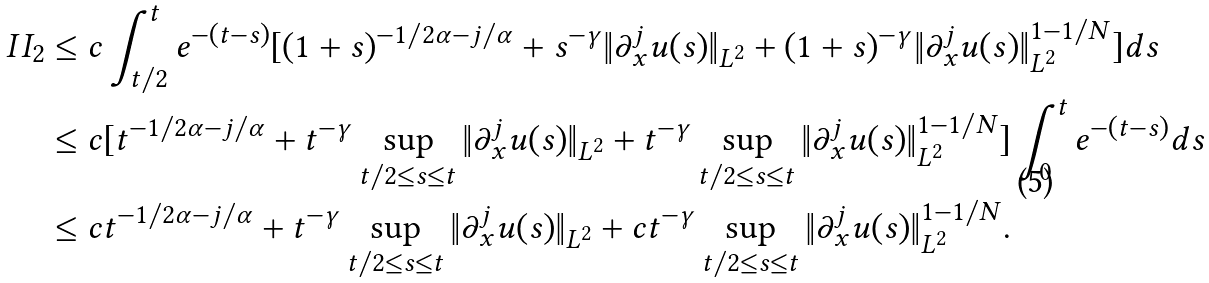Convert formula to latex. <formula><loc_0><loc_0><loc_500><loc_500>I I _ { 2 } & \leq c \int _ { t / 2 } ^ { t } e ^ { - ( t - s ) } [ ( 1 + s ) ^ { - 1 / 2 \alpha - j / \alpha } + s ^ { - \gamma } \| \partial _ { x } ^ { j } u ( s ) \| _ { L ^ { 2 } } + ( 1 + s ) ^ { - \gamma } \| \partial _ { x } ^ { j } u ( s ) \| _ { L ^ { 2 } } ^ { 1 - 1 / N } ] d s \\ & \leq c [ t ^ { - 1 / 2 \alpha - j / \alpha } + t ^ { - \gamma } \sup _ { t / 2 \leq s \leq t } \| \partial _ { x } ^ { j } u ( s ) \| _ { L ^ { 2 } } + t ^ { - \gamma } \sup _ { t / 2 \leq s \leq t } \| \partial _ { x } ^ { j } u ( s ) \| _ { L ^ { 2 } } ^ { 1 - 1 / N } ] \int _ { 0 } ^ { t } e ^ { - ( t - s ) } d s \\ & \leq c t ^ { - 1 / 2 \alpha - j / \alpha } + t ^ { - \gamma } \sup _ { t / 2 \leq s \leq t } \| \partial _ { x } ^ { j } u ( s ) \| _ { L ^ { 2 } } + c t ^ { - \gamma } \sup _ { t / 2 \leq s \leq t } \| \partial _ { x } ^ { j } u ( s ) \| _ { L ^ { 2 } } ^ { 1 - 1 / N } .</formula> 